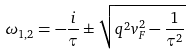<formula> <loc_0><loc_0><loc_500><loc_500>\omega _ { 1 , 2 } = - \frac { i } { \tau } \pm \sqrt { q ^ { 2 } v _ { F } ^ { 2 } - \frac { 1 } { \tau ^ { 2 } } }</formula> 